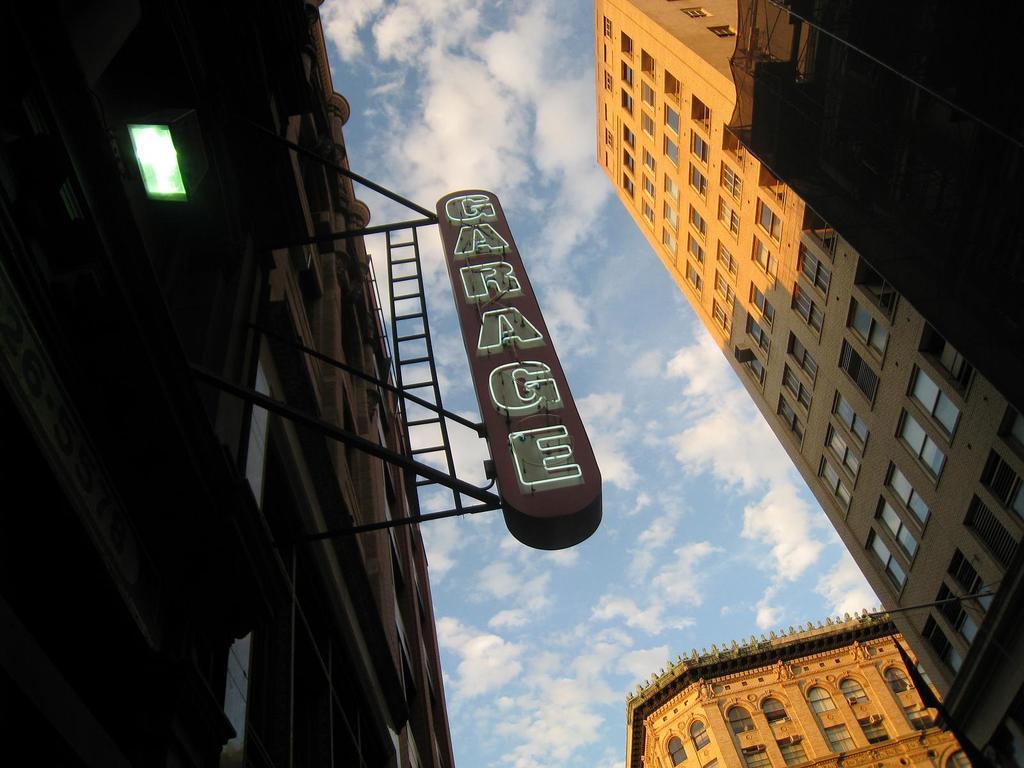Can you describe this image briefly? In the picture we can see three buildings with many floors and windows to it and to the building we can see a board with a name on it as GARAGE and on the top of the building we can see the sky with clouds. 